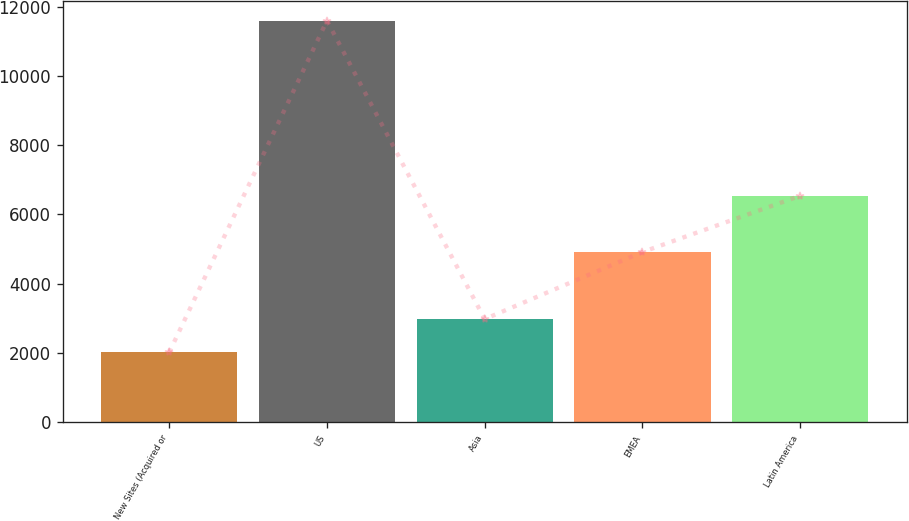<chart> <loc_0><loc_0><loc_500><loc_500><bar_chart><fcel>New Sites (Acquired or<fcel>US<fcel>Asia<fcel>EMEA<fcel>Latin America<nl><fcel>2015<fcel>11595<fcel>2973<fcel>4910<fcel>6535<nl></chart> 